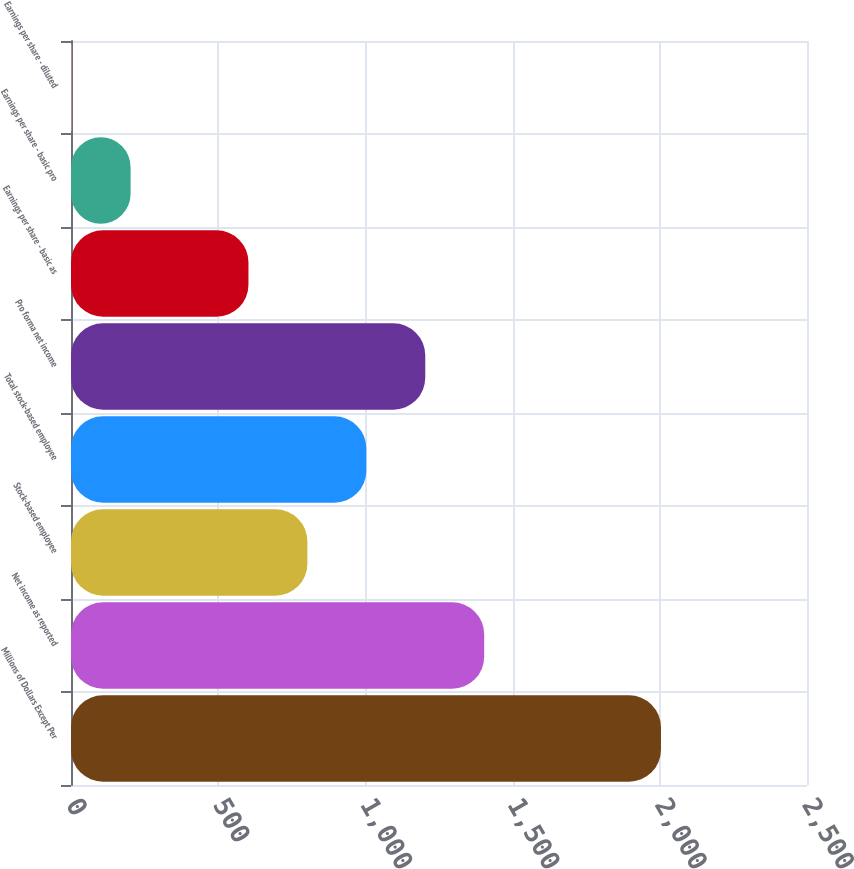<chart> <loc_0><loc_0><loc_500><loc_500><bar_chart><fcel>Millions of Dollars Except Per<fcel>Net income as reported<fcel>Stock-based employee<fcel>Total stock-based employee<fcel>Pro forma net income<fcel>Earnings per share - basic as<fcel>Earnings per share - basic pro<fcel>Earnings per share - diluted<nl><fcel>2004<fcel>1403.48<fcel>802.94<fcel>1003.12<fcel>1203.3<fcel>602.76<fcel>202.4<fcel>2.22<nl></chart> 